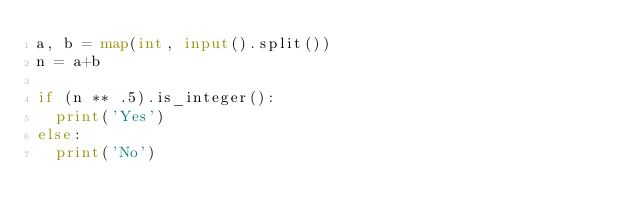Convert code to text. <code><loc_0><loc_0><loc_500><loc_500><_Python_>a, b = map(int, input().split())
n = a+b

if (n ** .5).is_integer():
	print('Yes')
else:
	print('No')</code> 